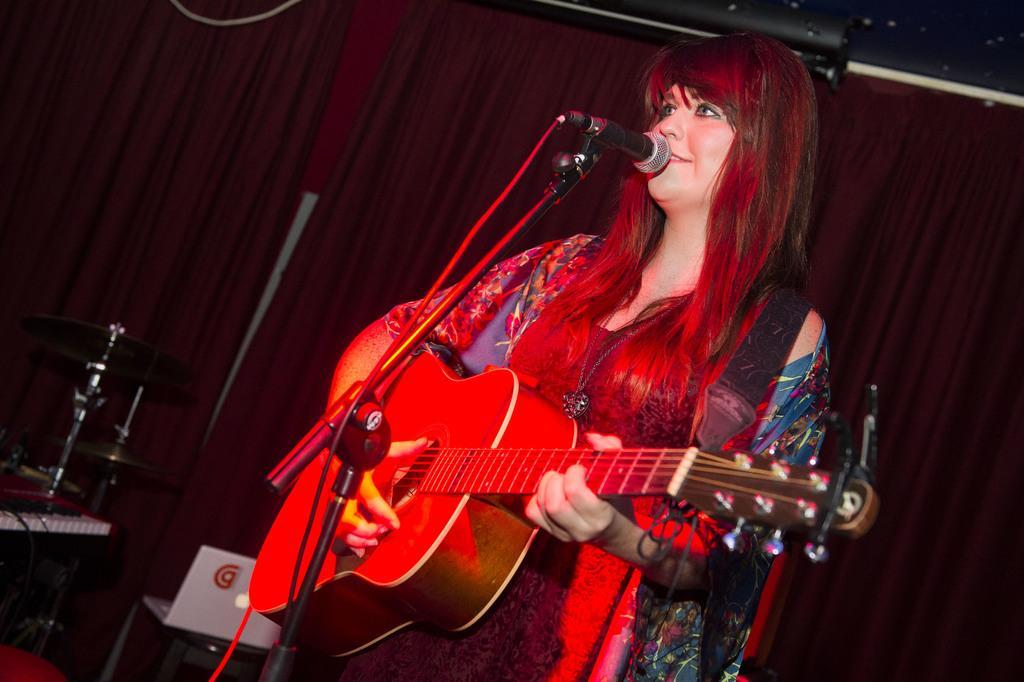In one or two sentences, can you explain what this image depicts? This picture shows a woman standing in front of a mic, holding a guitar in her hands. She is smiling. In the background there is a chair and a red color curtain here. 